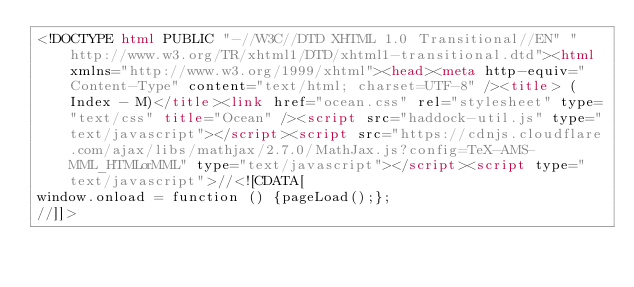<code> <loc_0><loc_0><loc_500><loc_500><_HTML_><!DOCTYPE html PUBLIC "-//W3C//DTD XHTML 1.0 Transitional//EN" "http://www.w3.org/TR/xhtml1/DTD/xhtml1-transitional.dtd"><html xmlns="http://www.w3.org/1999/xhtml"><head><meta http-equiv="Content-Type" content="text/html; charset=UTF-8" /><title> (Index - M)</title><link href="ocean.css" rel="stylesheet" type="text/css" title="Ocean" /><script src="haddock-util.js" type="text/javascript"></script><script src="https://cdnjs.cloudflare.com/ajax/libs/mathjax/2.7.0/MathJax.js?config=TeX-AMS-MML_HTMLorMML" type="text/javascript"></script><script type="text/javascript">//<![CDATA[
window.onload = function () {pageLoad();};
//]]></code> 